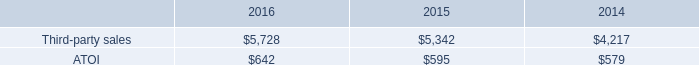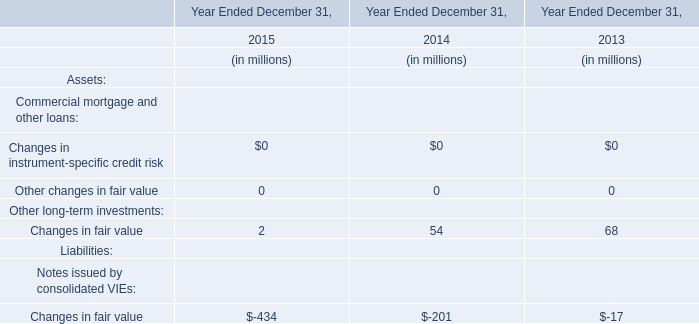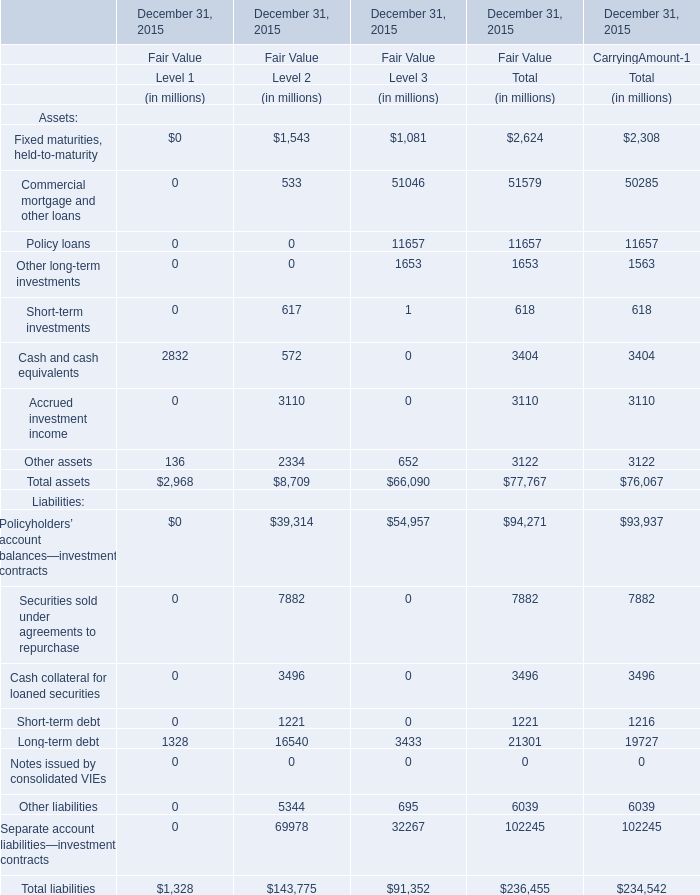What's the total value of all elements for Assets that are smaller than 4000 for CarryingAmount-1 of Total? (in million) 
Computations: (((((2308 + 1563) + 618) + 3404) + 3110) + 3122)
Answer: 14125.0. 